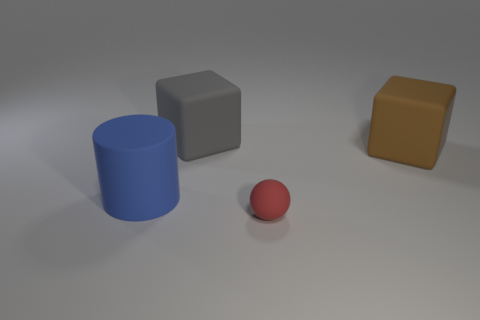Add 2 gray cylinders. How many objects exist? 6 Subtract all cylinders. How many objects are left? 3 Add 2 large cylinders. How many large cylinders are left? 3 Add 3 tiny matte balls. How many tiny matte balls exist? 4 Subtract 0 purple cylinders. How many objects are left? 4 Subtract all gray matte cubes. Subtract all big cylinders. How many objects are left? 2 